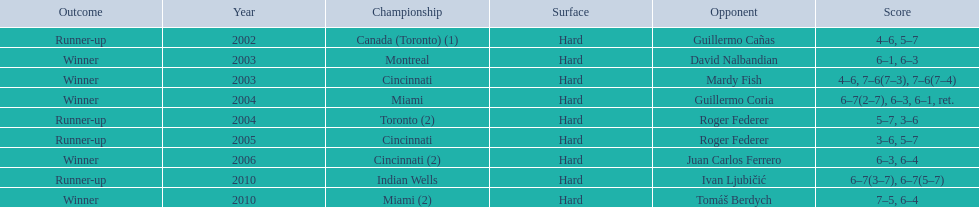What was the greatest number of back-to-back wins recorded? 3. Parse the table in full. {'header': ['Outcome', 'Year', 'Championship', 'Surface', 'Opponent', 'Score'], 'rows': [['Runner-up', '2002', 'Canada (Toronto) (1)', 'Hard', 'Guillermo Cañas', '4–6, 5–7'], ['Winner', '2003', 'Montreal', 'Hard', 'David Nalbandian', '6–1, 6–3'], ['Winner', '2003', 'Cincinnati', 'Hard', 'Mardy Fish', '4–6, 7–6(7–3), 7–6(7–4)'], ['Winner', '2004', 'Miami', 'Hard', 'Guillermo Coria', '6–7(2–7), 6–3, 6–1, ret.'], ['Runner-up', '2004', 'Toronto (2)', 'Hard', 'Roger Federer', '5–7, 3–6'], ['Runner-up', '2005', 'Cincinnati', 'Hard', 'Roger Federer', '3–6, 5–7'], ['Winner', '2006', 'Cincinnati (2)', 'Hard', 'Juan Carlos Ferrero', '6–3, 6–4'], ['Runner-up', '2010', 'Indian Wells', 'Hard', 'Ivan Ljubičić', '6–7(3–7), 6–7(5–7)'], ['Winner', '2010', 'Miami (2)', 'Hard', 'Tomáš Berdych', '7–5, 6–4']]} 